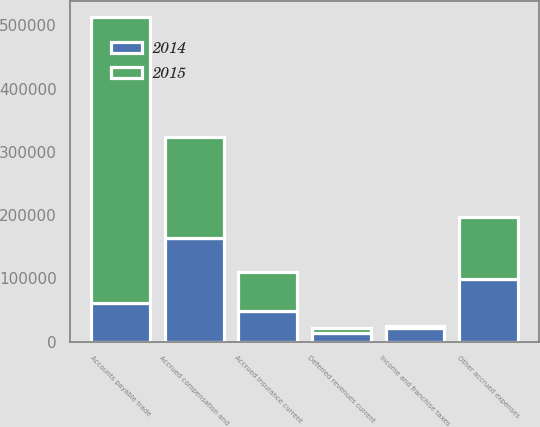Convert chart to OTSL. <chart><loc_0><loc_0><loc_500><loc_500><stacked_bar_chart><ecel><fcel>Accounts payable trade<fcel>Accrued compensation and<fcel>Accrued insurance current<fcel>Deferred revenues current<fcel>Income and franchise taxes<fcel>Other accrued expenses<nl><fcel>2015<fcel>452295<fcel>159045<fcel>61327<fcel>8010<fcel>3923<fcel>97534<nl><fcel>2014<fcel>61327<fcel>164777<fcel>49309<fcel>13082<fcel>20946<fcel>99747<nl></chart> 